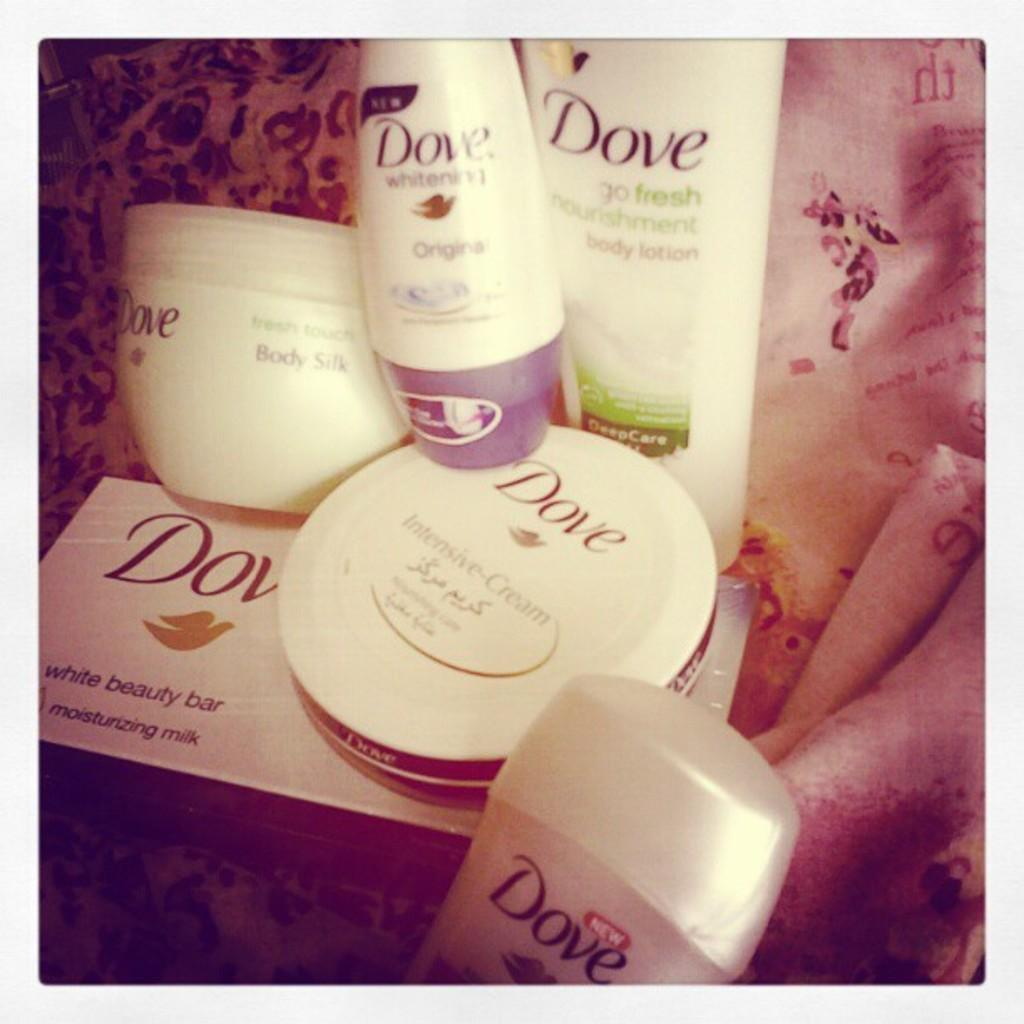Provide a one-sentence caption for the provided image. Bunch of Dove beauty products placed strategically together. 